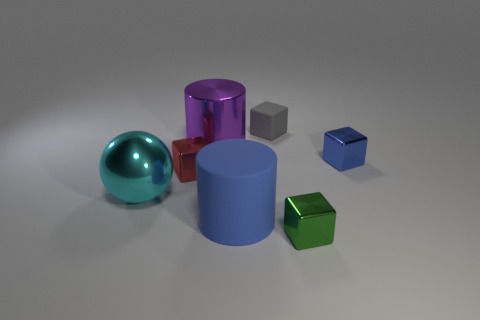Subtract all tiny gray matte blocks. How many blocks are left? 3 Subtract 2 blocks. How many blocks are left? 2 Subtract all red cubes. How many cubes are left? 3 Add 1 large matte cylinders. How many objects exist? 8 Subtract all blue cubes. Subtract all brown cylinders. How many cubes are left? 3 Add 3 small green metallic things. How many small green metallic things exist? 4 Subtract 0 green cylinders. How many objects are left? 7 Subtract all blocks. How many objects are left? 3 Subtract all tiny red metal objects. Subtract all red metallic blocks. How many objects are left? 5 Add 1 large cyan shiny spheres. How many large cyan shiny spheres are left? 2 